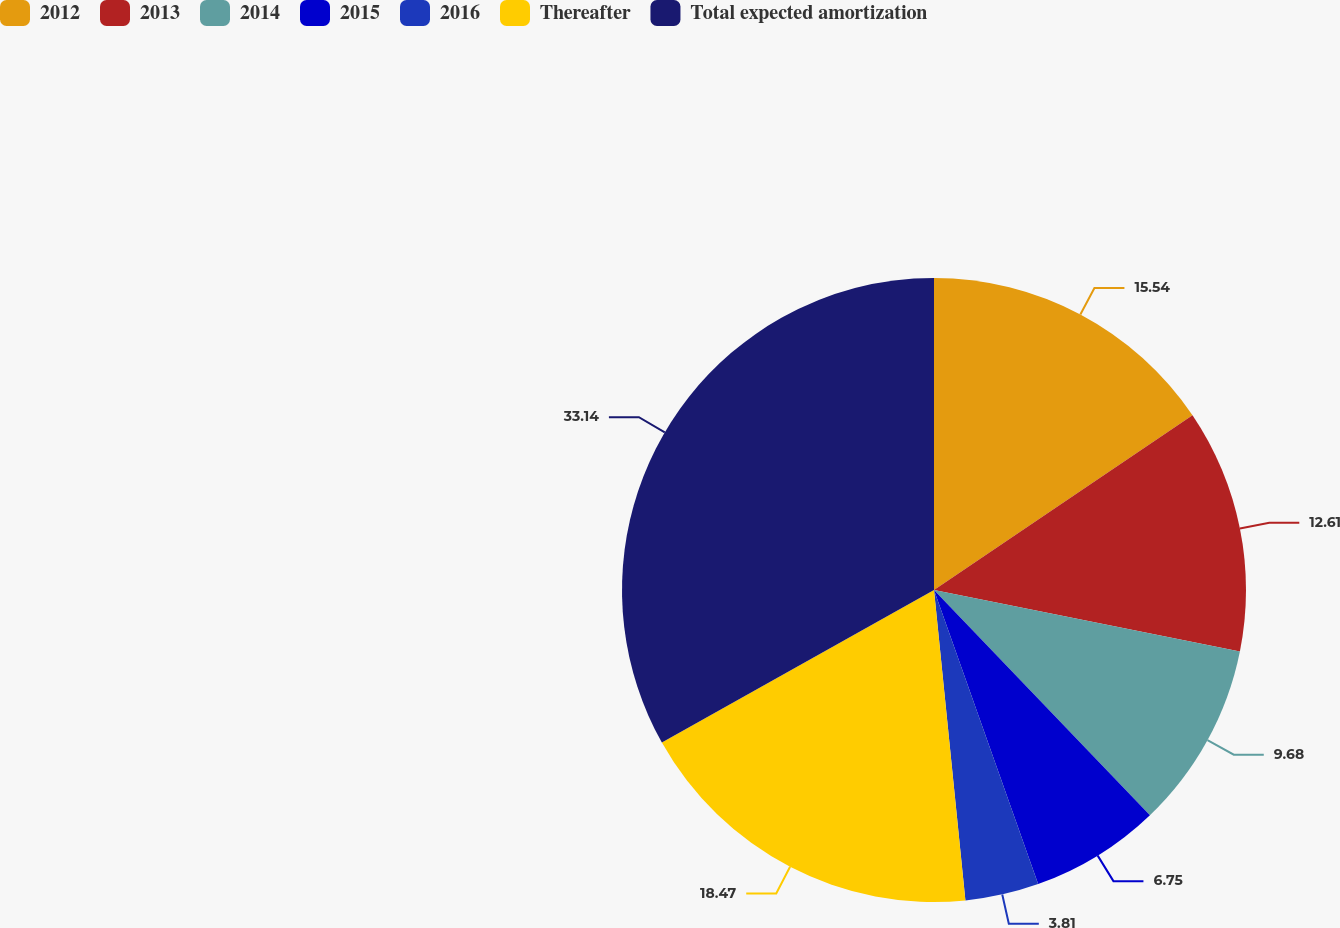Convert chart. <chart><loc_0><loc_0><loc_500><loc_500><pie_chart><fcel>2012<fcel>2013<fcel>2014<fcel>2015<fcel>2016<fcel>Thereafter<fcel>Total expected amortization<nl><fcel>15.54%<fcel>12.61%<fcel>9.68%<fcel>6.75%<fcel>3.81%<fcel>18.47%<fcel>33.13%<nl></chart> 